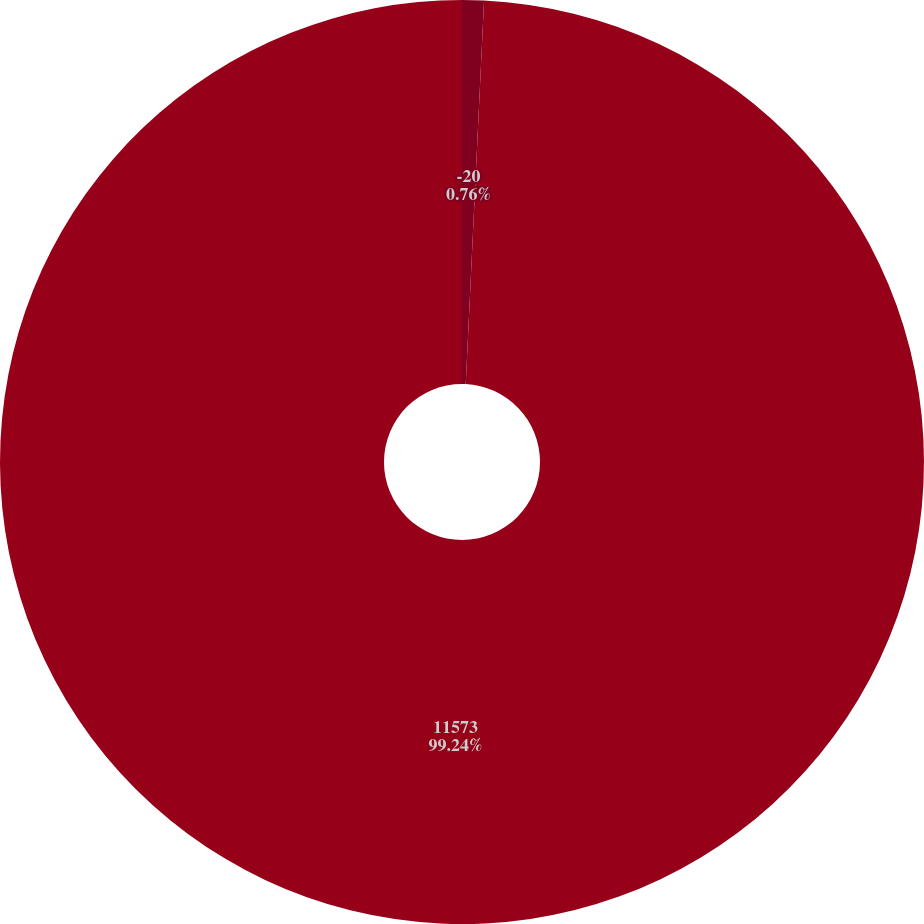Convert chart. <chart><loc_0><loc_0><loc_500><loc_500><pie_chart><fcel>-20<fcel>11573<nl><fcel>0.76%<fcel>99.24%<nl></chart> 